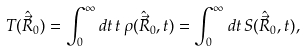Convert formula to latex. <formula><loc_0><loc_0><loc_500><loc_500>T ( \hat { \vec { R } } _ { 0 } ) = \int _ { 0 } ^ { \infty } d t \, t \, \rho ( \hat { \vec { R } } _ { 0 } , t ) = \int _ { 0 } ^ { \infty } d t \, S ( \hat { \vec { R } } _ { 0 } , t ) ,</formula> 